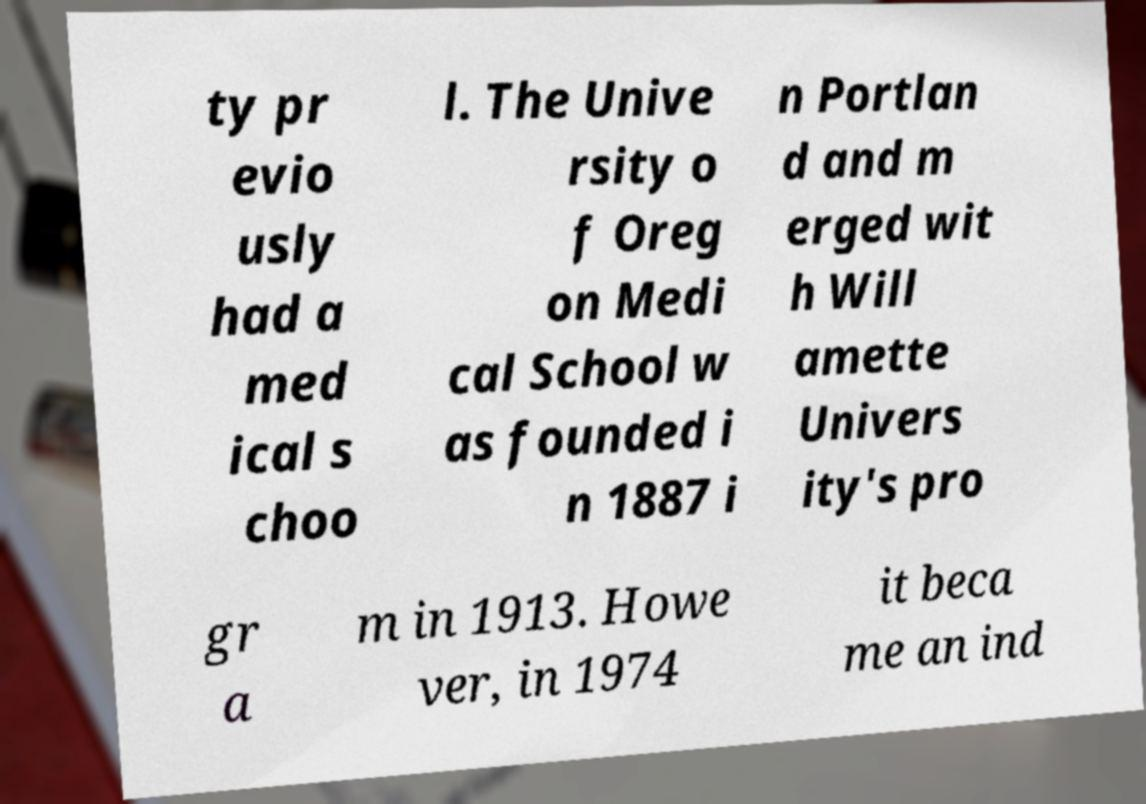Could you extract and type out the text from this image? ty pr evio usly had a med ical s choo l. The Unive rsity o f Oreg on Medi cal School w as founded i n 1887 i n Portlan d and m erged wit h Will amette Univers ity's pro gr a m in 1913. Howe ver, in 1974 it beca me an ind 